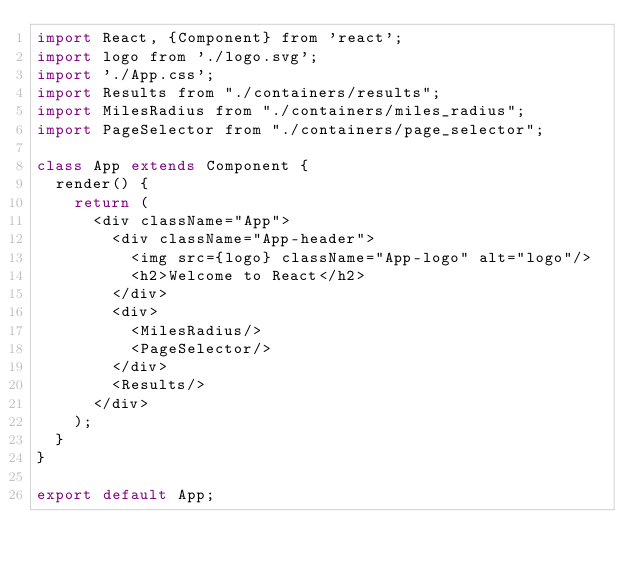<code> <loc_0><loc_0><loc_500><loc_500><_JavaScript_>import React, {Component} from 'react';
import logo from './logo.svg';
import './App.css';
import Results from "./containers/results";
import MilesRadius from "./containers/miles_radius";
import PageSelector from "./containers/page_selector";

class App extends Component {
	render() {
		return (
			<div className="App">
				<div className="App-header">
					<img src={logo} className="App-logo" alt="logo"/>
					<h2>Welcome to React</h2>
				</div>
				<div>
					<MilesRadius/>
					<PageSelector/>
				</div>
				<Results/>
			</div>
		);
	}
}

export default App;
</code> 